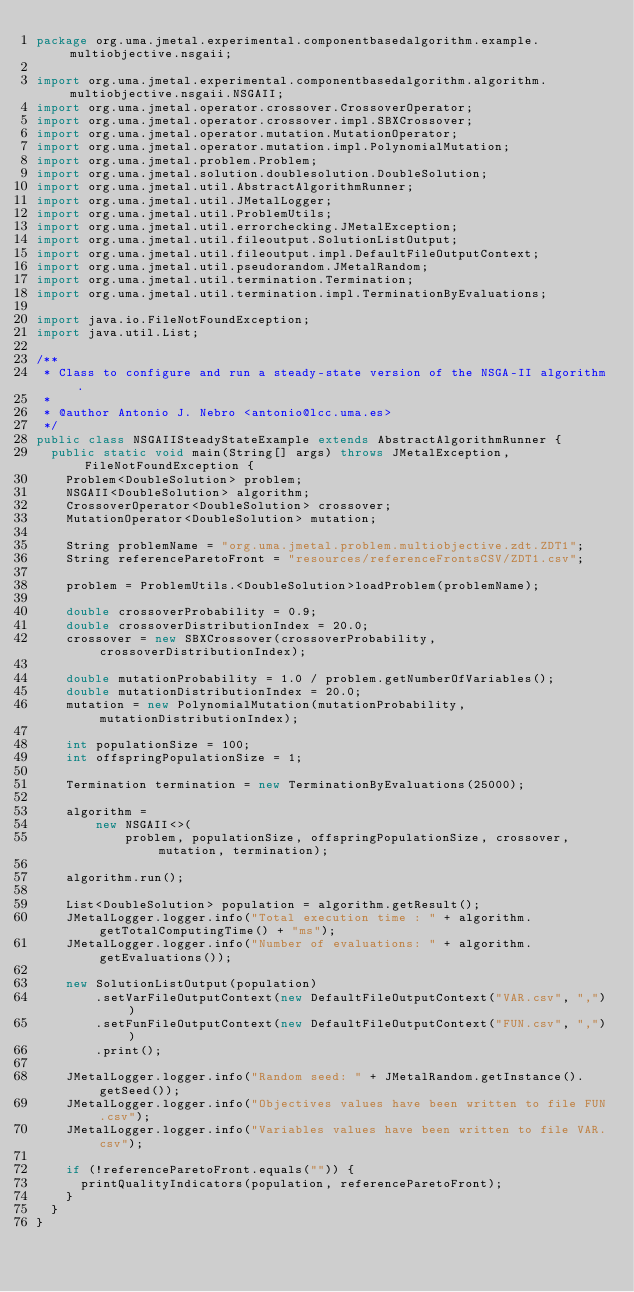Convert code to text. <code><loc_0><loc_0><loc_500><loc_500><_Java_>package org.uma.jmetal.experimental.componentbasedalgorithm.example.multiobjective.nsgaii;

import org.uma.jmetal.experimental.componentbasedalgorithm.algorithm.multiobjective.nsgaii.NSGAII;
import org.uma.jmetal.operator.crossover.CrossoverOperator;
import org.uma.jmetal.operator.crossover.impl.SBXCrossover;
import org.uma.jmetal.operator.mutation.MutationOperator;
import org.uma.jmetal.operator.mutation.impl.PolynomialMutation;
import org.uma.jmetal.problem.Problem;
import org.uma.jmetal.solution.doublesolution.DoubleSolution;
import org.uma.jmetal.util.AbstractAlgorithmRunner;
import org.uma.jmetal.util.JMetalLogger;
import org.uma.jmetal.util.ProblemUtils;
import org.uma.jmetal.util.errorchecking.JMetalException;
import org.uma.jmetal.util.fileoutput.SolutionListOutput;
import org.uma.jmetal.util.fileoutput.impl.DefaultFileOutputContext;
import org.uma.jmetal.util.pseudorandom.JMetalRandom;
import org.uma.jmetal.util.termination.Termination;
import org.uma.jmetal.util.termination.impl.TerminationByEvaluations;

import java.io.FileNotFoundException;
import java.util.List;

/**
 * Class to configure and run a steady-state version of the NSGA-II algorithm.
 *
 * @author Antonio J. Nebro <antonio@lcc.uma.es>
 */
public class NSGAIISteadyStateExample extends AbstractAlgorithmRunner {
  public static void main(String[] args) throws JMetalException, FileNotFoundException {
    Problem<DoubleSolution> problem;
    NSGAII<DoubleSolution> algorithm;
    CrossoverOperator<DoubleSolution> crossover;
    MutationOperator<DoubleSolution> mutation;

    String problemName = "org.uma.jmetal.problem.multiobjective.zdt.ZDT1";
    String referenceParetoFront = "resources/referenceFrontsCSV/ZDT1.csv";

    problem = ProblemUtils.<DoubleSolution>loadProblem(problemName);

    double crossoverProbability = 0.9;
    double crossoverDistributionIndex = 20.0;
    crossover = new SBXCrossover(crossoverProbability, crossoverDistributionIndex);

    double mutationProbability = 1.0 / problem.getNumberOfVariables();
    double mutationDistributionIndex = 20.0;
    mutation = new PolynomialMutation(mutationProbability, mutationDistributionIndex);

    int populationSize = 100;
    int offspringPopulationSize = 1;

    Termination termination = new TerminationByEvaluations(25000);

    algorithm =
        new NSGAII<>(
            problem, populationSize, offspringPopulationSize, crossover, mutation, termination);

    algorithm.run();

    List<DoubleSolution> population = algorithm.getResult();
    JMetalLogger.logger.info("Total execution time : " + algorithm.getTotalComputingTime() + "ms");
    JMetalLogger.logger.info("Number of evaluations: " + algorithm.getEvaluations());

    new SolutionListOutput(population)
        .setVarFileOutputContext(new DefaultFileOutputContext("VAR.csv", ","))
        .setFunFileOutputContext(new DefaultFileOutputContext("FUN.csv", ","))
        .print();

    JMetalLogger.logger.info("Random seed: " + JMetalRandom.getInstance().getSeed());
    JMetalLogger.logger.info("Objectives values have been written to file FUN.csv");
    JMetalLogger.logger.info("Variables values have been written to file VAR.csv");

    if (!referenceParetoFront.equals("")) {
      printQualityIndicators(population, referenceParetoFront);
    }
  }
}
</code> 